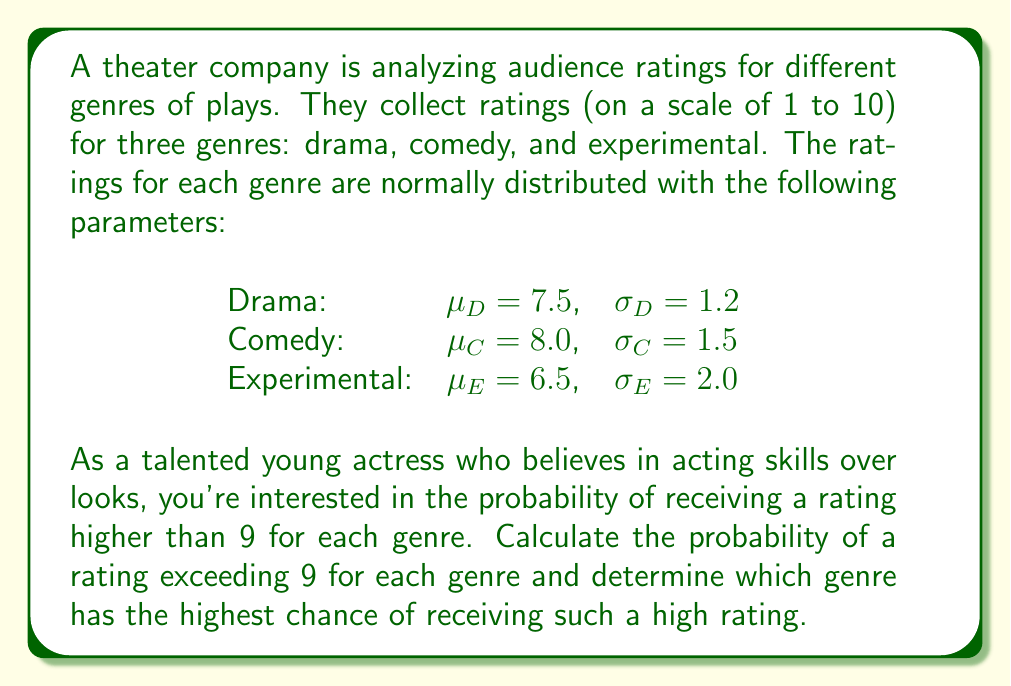Can you solve this math problem? To solve this problem, we need to calculate the probability of a rating exceeding 9 for each genre using the standard normal distribution (z-score) method. We'll follow these steps for each genre:

1. Calculate the z-score for a rating of 9.
2. Find the probability using the standard normal distribution table or function.
3. Subtract the result from 1 to get the probability of exceeding 9.

For Drama:
1. $z_D = \frac{9 - \mu_D}{\sigma_D} = \frac{9 - 7.5}{1.2} = 1.25$
2. $P(Z < 1.25) \approx 0.8944$
3. $P(\text{Rating}_D > 9) = 1 - 0.8944 = 0.1056$

For Comedy:
1. $z_C = \frac{9 - \mu_C}{\sigma_C} = \frac{9 - 8.0}{1.5} = 0.67$
2. $P(Z < 0.67) \approx 0.7486$
3. $P(\text{Rating}_C > 9) = 1 - 0.7486 = 0.2514$

For Experimental:
1. $z_E = \frac{9 - \mu_E}{\sigma_E} = \frac{9 - 6.5}{2.0} = 1.25$
2. $P(Z < 1.25) \approx 0.8944$
3. $P(\text{Rating}_E > 9) = 1 - 0.8944 = 0.1056$

Comparing the probabilities:
Comedy: 0.2514 (25.14%)
Drama: 0.1056 (10.56%)
Experimental: 0.1056 (10.56%)

The genre with the highest chance of receiving a rating higher than 9 is Comedy.
Answer: Comedy has the highest probability (25.14%) of receiving a rating above 9. 